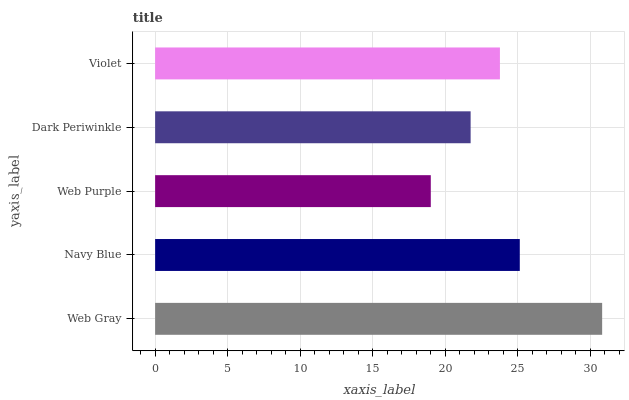Is Web Purple the minimum?
Answer yes or no. Yes. Is Web Gray the maximum?
Answer yes or no. Yes. Is Navy Blue the minimum?
Answer yes or no. No. Is Navy Blue the maximum?
Answer yes or no. No. Is Web Gray greater than Navy Blue?
Answer yes or no. Yes. Is Navy Blue less than Web Gray?
Answer yes or no. Yes. Is Navy Blue greater than Web Gray?
Answer yes or no. No. Is Web Gray less than Navy Blue?
Answer yes or no. No. Is Violet the high median?
Answer yes or no. Yes. Is Violet the low median?
Answer yes or no. Yes. Is Navy Blue the high median?
Answer yes or no. No. Is Dark Periwinkle the low median?
Answer yes or no. No. 